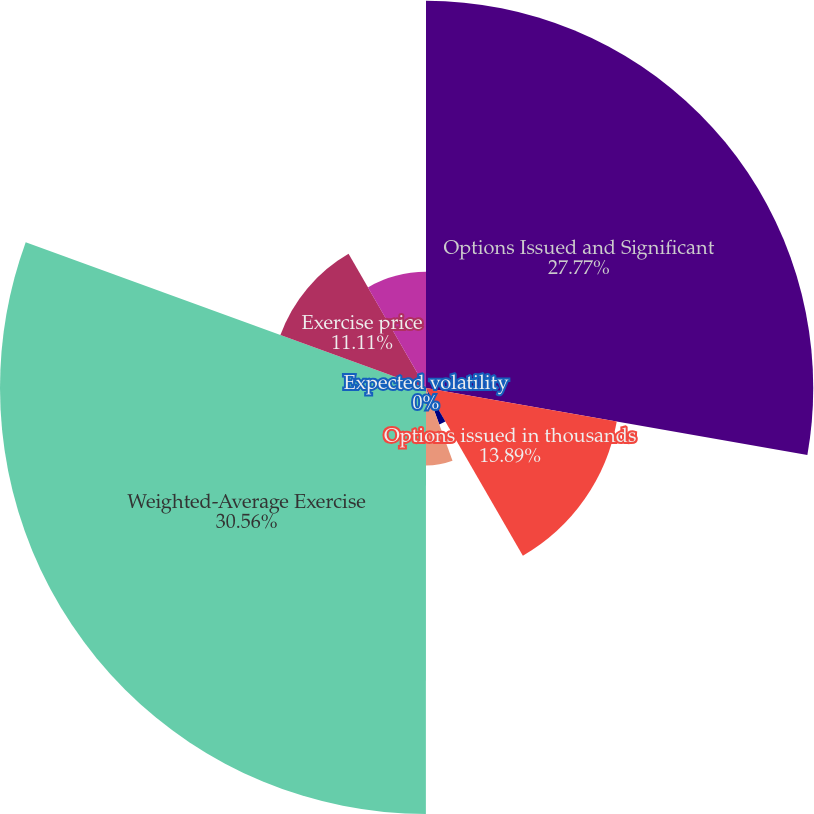Convert chart. <chart><loc_0><loc_0><loc_500><loc_500><pie_chart><fcel>Options Issued and Significant<fcel>Options issued in thousands<fcel>Risk-free interest rate<fcel>Expected life in years<fcel>Expected volatility<fcel>Weighted-Average Exercise<fcel>Exercise price<fcel>Fair value<nl><fcel>27.77%<fcel>13.89%<fcel>2.78%<fcel>5.56%<fcel>0.0%<fcel>30.55%<fcel>11.11%<fcel>8.33%<nl></chart> 